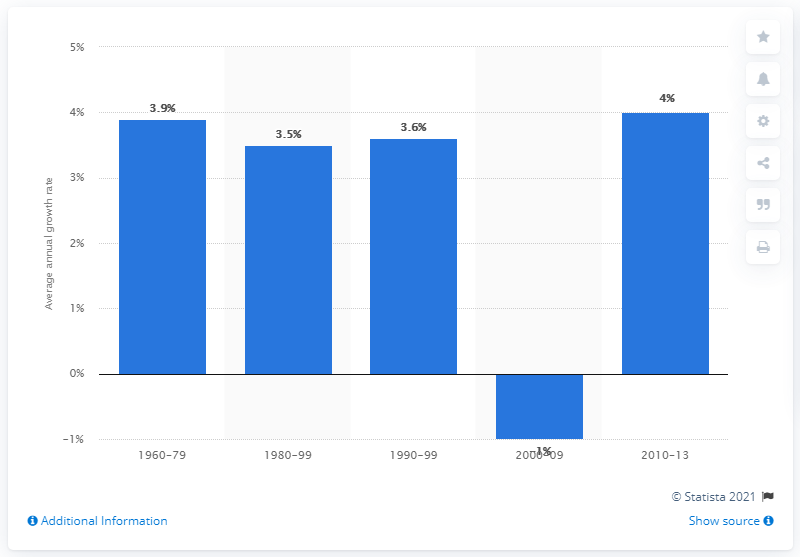Highlight a few significant elements in this photo. The manufacturing sector's output increased significantly from 2010 to 2013. 